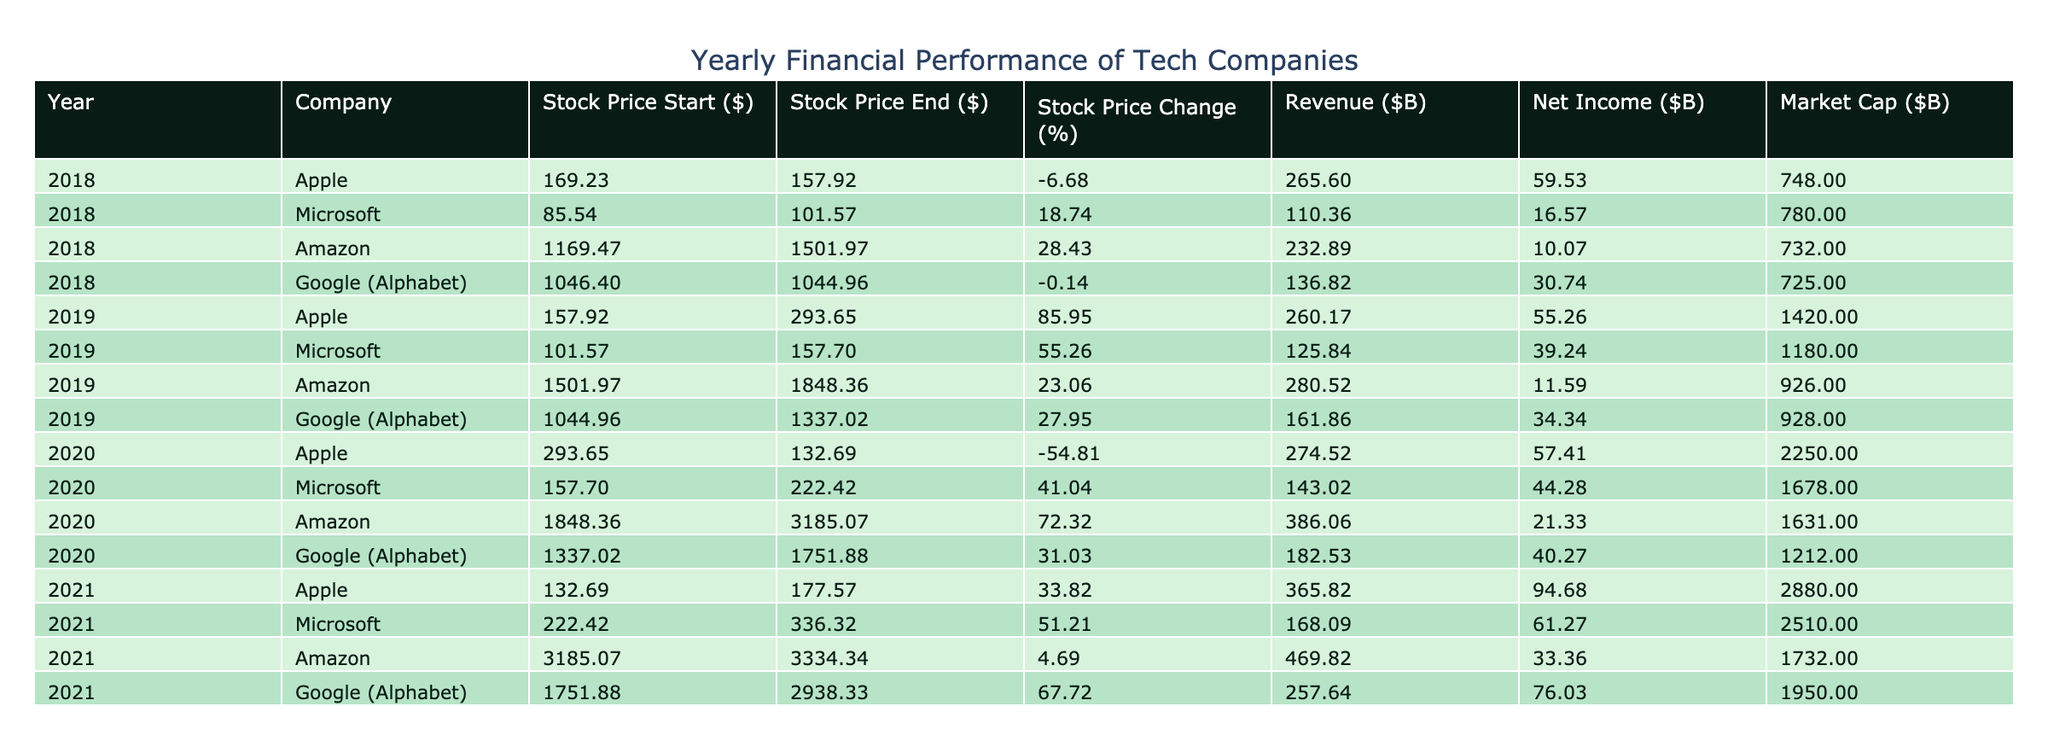What was the Stock Price End for Microsoft in 2019? From the table, look for the row that corresponds to Microsoft in 2019. The value for Stock Price End (USD) listed for Microsoft in 2019 is 157.70.
Answer: 157.70 Which company had the highest Market Cap in 2021? Reviewing the Market Cap values for all companies in 2021, Apple has a Market Cap of 2880.00 billion USD, which is greater than the Market Caps of Microsoft (2510.00), Amazon (1732.00), and Google (1950.00). Therefore, Apple had the highest Market Cap in 2021.
Answer: Apple What is the total Revenue of all companies for the year 2020? The Revenue values for each company in 2020 are: Apple (274.52), Microsoft (143.02), Amazon (386.06), and Google (182.53). Summing these values gives a total Revenue of 274.52 + 143.02 + 386.06 + 182.53 = 986.13 billion USD.
Answer: 986.13 Did Amazon's Stock Price Change percentage increase from 2019 to 2020? To find this out, we need to calculate the Stock Price Change percentage for Amazon in both years. In 2019, the percentage change is ((1848.36 - 1501.97) / 1501.97) * 100 ≈ 23.07%. In 2020, it's ((3185.07 - 1848.36) / 1848.36) * 100 ≈ 72.51%. Since 72.51% is greater than 23.07%, we conclude that Amazon's Stock Price Change percentage did increase from 2019 to 2020.
Answer: Yes What was the average Net Income of all companies in 2018? The Net Income values for 2018 from the table are: Apple (59.53), Microsoft (16.57), Amazon (10.07), and Google (30.74). To find the average, sum these values: 59.53 + 16.57 + 10.07 + 30.74 = 116.91 billion USD. Then, divide by the number of companies (4): 116.91 / 4 = 29.23.
Answer: 29.23 Which year did Google (Alphabet) have the highest revenue? The revenue values for Google in each year are: 136.82 (2018), 161.86 (2019), 182.53 (2020), and 257.64 (2021). Examining these values shows that the highest revenue is 257.64 billion USD in 2021.
Answer: 2021 What was the difference in Stock Price Start between Apple and Amazon in 2020? From the table, Apple's Stock Price Start in 2020 is 293.65 USD, and Amazon's is 1848.36 USD. To find the difference, subtract Apple's price from Amazon's: 1848.36 - 293.65 = 1554.71 USD.
Answer: 1554.71 Did all companies experience a decrease in Stock Price from 2020 to 2021? For 2021, the Stock Price End values are: Apple (177.57), Microsoft (336.32), Amazon (3334.34), and Google (2938.33). Comparing these with the Stock Price End values of 2020 shows that all companies, except for Microsoft (increased from 222.42 to 336.32), experienced price decreases or increases, meaning not all had a decrease. Thus, the statement is false.
Answer: No 